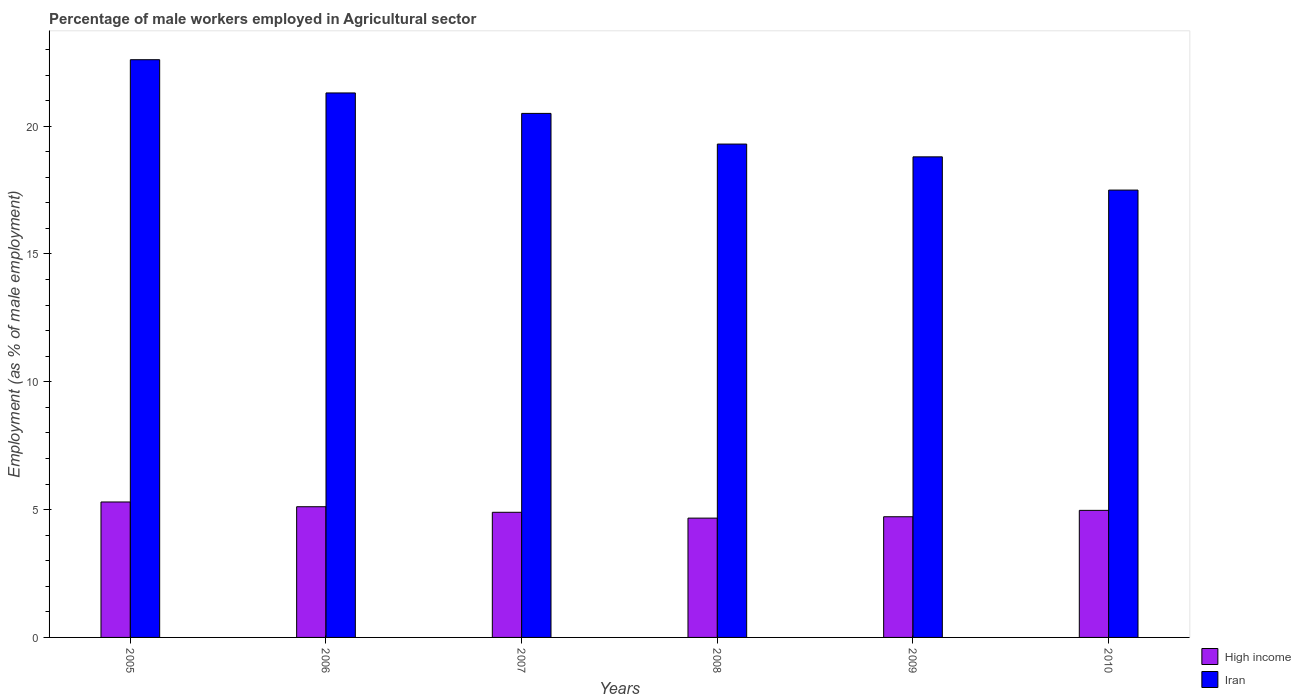How many different coloured bars are there?
Keep it short and to the point. 2. How many groups of bars are there?
Provide a succinct answer. 6. Are the number of bars per tick equal to the number of legend labels?
Provide a short and direct response. Yes. How many bars are there on the 3rd tick from the right?
Provide a succinct answer. 2. What is the label of the 5th group of bars from the left?
Your answer should be very brief. 2009. What is the percentage of male workers employed in Agricultural sector in High income in 2006?
Your answer should be compact. 5.11. Across all years, what is the maximum percentage of male workers employed in Agricultural sector in Iran?
Offer a very short reply. 22.6. In which year was the percentage of male workers employed in Agricultural sector in High income maximum?
Ensure brevity in your answer.  2005. In which year was the percentage of male workers employed in Agricultural sector in High income minimum?
Your response must be concise. 2008. What is the total percentage of male workers employed in Agricultural sector in High income in the graph?
Offer a terse response. 29.67. What is the difference between the percentage of male workers employed in Agricultural sector in High income in 2007 and that in 2009?
Offer a very short reply. 0.17. What is the difference between the percentage of male workers employed in Agricultural sector in Iran in 2007 and the percentage of male workers employed in Agricultural sector in High income in 2006?
Make the answer very short. 15.39. What is the average percentage of male workers employed in Agricultural sector in High income per year?
Offer a terse response. 4.94. In the year 2007, what is the difference between the percentage of male workers employed in Agricultural sector in Iran and percentage of male workers employed in Agricultural sector in High income?
Offer a terse response. 15.6. In how many years, is the percentage of male workers employed in Agricultural sector in High income greater than 20 %?
Offer a terse response. 0. What is the ratio of the percentage of male workers employed in Agricultural sector in High income in 2006 to that in 2010?
Keep it short and to the point. 1.03. Is the difference between the percentage of male workers employed in Agricultural sector in Iran in 2007 and 2009 greater than the difference between the percentage of male workers employed in Agricultural sector in High income in 2007 and 2009?
Your answer should be very brief. Yes. What is the difference between the highest and the second highest percentage of male workers employed in Agricultural sector in Iran?
Ensure brevity in your answer.  1.3. What is the difference between the highest and the lowest percentage of male workers employed in Agricultural sector in High income?
Offer a terse response. 0.63. In how many years, is the percentage of male workers employed in Agricultural sector in Iran greater than the average percentage of male workers employed in Agricultural sector in Iran taken over all years?
Your answer should be very brief. 3. Is the sum of the percentage of male workers employed in Agricultural sector in Iran in 2006 and 2010 greater than the maximum percentage of male workers employed in Agricultural sector in High income across all years?
Ensure brevity in your answer.  Yes. What does the 1st bar from the left in 2006 represents?
Provide a short and direct response. High income. What does the 2nd bar from the right in 2009 represents?
Give a very brief answer. High income. How many bars are there?
Provide a short and direct response. 12. Are all the bars in the graph horizontal?
Keep it short and to the point. No. How many years are there in the graph?
Provide a succinct answer. 6. Are the values on the major ticks of Y-axis written in scientific E-notation?
Your answer should be compact. No. Does the graph contain any zero values?
Make the answer very short. No. How many legend labels are there?
Offer a very short reply. 2. How are the legend labels stacked?
Provide a succinct answer. Vertical. What is the title of the graph?
Keep it short and to the point. Percentage of male workers employed in Agricultural sector. Does "Italy" appear as one of the legend labels in the graph?
Offer a very short reply. No. What is the label or title of the X-axis?
Provide a short and direct response. Years. What is the label or title of the Y-axis?
Your response must be concise. Employment (as % of male employment). What is the Employment (as % of male employment) in High income in 2005?
Provide a succinct answer. 5.3. What is the Employment (as % of male employment) of Iran in 2005?
Provide a succinct answer. 22.6. What is the Employment (as % of male employment) of High income in 2006?
Your answer should be very brief. 5.11. What is the Employment (as % of male employment) in Iran in 2006?
Your answer should be compact. 21.3. What is the Employment (as % of male employment) of High income in 2007?
Make the answer very short. 4.9. What is the Employment (as % of male employment) of Iran in 2007?
Your response must be concise. 20.5. What is the Employment (as % of male employment) of High income in 2008?
Make the answer very short. 4.67. What is the Employment (as % of male employment) of Iran in 2008?
Provide a succinct answer. 19.3. What is the Employment (as % of male employment) in High income in 2009?
Keep it short and to the point. 4.72. What is the Employment (as % of male employment) of Iran in 2009?
Make the answer very short. 18.8. What is the Employment (as % of male employment) in High income in 2010?
Keep it short and to the point. 4.97. What is the Employment (as % of male employment) in Iran in 2010?
Offer a terse response. 17.5. Across all years, what is the maximum Employment (as % of male employment) of High income?
Ensure brevity in your answer.  5.3. Across all years, what is the maximum Employment (as % of male employment) of Iran?
Your response must be concise. 22.6. Across all years, what is the minimum Employment (as % of male employment) in High income?
Offer a terse response. 4.67. What is the total Employment (as % of male employment) of High income in the graph?
Ensure brevity in your answer.  29.67. What is the total Employment (as % of male employment) in Iran in the graph?
Give a very brief answer. 120. What is the difference between the Employment (as % of male employment) in High income in 2005 and that in 2006?
Offer a terse response. 0.19. What is the difference between the Employment (as % of male employment) of Iran in 2005 and that in 2006?
Offer a very short reply. 1.3. What is the difference between the Employment (as % of male employment) of High income in 2005 and that in 2007?
Make the answer very short. 0.4. What is the difference between the Employment (as % of male employment) of High income in 2005 and that in 2008?
Ensure brevity in your answer.  0.63. What is the difference between the Employment (as % of male employment) in Iran in 2005 and that in 2008?
Offer a very short reply. 3.3. What is the difference between the Employment (as % of male employment) of High income in 2005 and that in 2009?
Ensure brevity in your answer.  0.58. What is the difference between the Employment (as % of male employment) in Iran in 2005 and that in 2009?
Your response must be concise. 3.8. What is the difference between the Employment (as % of male employment) of High income in 2005 and that in 2010?
Keep it short and to the point. 0.33. What is the difference between the Employment (as % of male employment) in High income in 2006 and that in 2007?
Your answer should be very brief. 0.22. What is the difference between the Employment (as % of male employment) in Iran in 2006 and that in 2007?
Ensure brevity in your answer.  0.8. What is the difference between the Employment (as % of male employment) of High income in 2006 and that in 2008?
Your answer should be very brief. 0.45. What is the difference between the Employment (as % of male employment) in High income in 2006 and that in 2009?
Provide a succinct answer. 0.39. What is the difference between the Employment (as % of male employment) of High income in 2006 and that in 2010?
Your answer should be very brief. 0.14. What is the difference between the Employment (as % of male employment) in Iran in 2006 and that in 2010?
Your answer should be very brief. 3.8. What is the difference between the Employment (as % of male employment) in High income in 2007 and that in 2008?
Give a very brief answer. 0.23. What is the difference between the Employment (as % of male employment) of Iran in 2007 and that in 2008?
Make the answer very short. 1.2. What is the difference between the Employment (as % of male employment) in High income in 2007 and that in 2009?
Make the answer very short. 0.17. What is the difference between the Employment (as % of male employment) of Iran in 2007 and that in 2009?
Your answer should be compact. 1.7. What is the difference between the Employment (as % of male employment) of High income in 2007 and that in 2010?
Provide a short and direct response. -0.08. What is the difference between the Employment (as % of male employment) of High income in 2008 and that in 2009?
Provide a succinct answer. -0.05. What is the difference between the Employment (as % of male employment) in High income in 2008 and that in 2010?
Ensure brevity in your answer.  -0.3. What is the difference between the Employment (as % of male employment) of Iran in 2008 and that in 2010?
Your answer should be very brief. 1.8. What is the difference between the Employment (as % of male employment) in High income in 2009 and that in 2010?
Ensure brevity in your answer.  -0.25. What is the difference between the Employment (as % of male employment) in Iran in 2009 and that in 2010?
Your answer should be very brief. 1.3. What is the difference between the Employment (as % of male employment) in High income in 2005 and the Employment (as % of male employment) in Iran in 2006?
Give a very brief answer. -16. What is the difference between the Employment (as % of male employment) in High income in 2005 and the Employment (as % of male employment) in Iran in 2007?
Offer a terse response. -15.2. What is the difference between the Employment (as % of male employment) of High income in 2005 and the Employment (as % of male employment) of Iran in 2008?
Provide a succinct answer. -14. What is the difference between the Employment (as % of male employment) in High income in 2005 and the Employment (as % of male employment) in Iran in 2009?
Your answer should be compact. -13.5. What is the difference between the Employment (as % of male employment) in High income in 2005 and the Employment (as % of male employment) in Iran in 2010?
Your answer should be compact. -12.2. What is the difference between the Employment (as % of male employment) of High income in 2006 and the Employment (as % of male employment) of Iran in 2007?
Your response must be concise. -15.39. What is the difference between the Employment (as % of male employment) in High income in 2006 and the Employment (as % of male employment) in Iran in 2008?
Make the answer very short. -14.19. What is the difference between the Employment (as % of male employment) in High income in 2006 and the Employment (as % of male employment) in Iran in 2009?
Give a very brief answer. -13.69. What is the difference between the Employment (as % of male employment) of High income in 2006 and the Employment (as % of male employment) of Iran in 2010?
Your answer should be compact. -12.39. What is the difference between the Employment (as % of male employment) of High income in 2007 and the Employment (as % of male employment) of Iran in 2008?
Provide a succinct answer. -14.4. What is the difference between the Employment (as % of male employment) in High income in 2007 and the Employment (as % of male employment) in Iran in 2009?
Provide a short and direct response. -13.9. What is the difference between the Employment (as % of male employment) in High income in 2007 and the Employment (as % of male employment) in Iran in 2010?
Your response must be concise. -12.6. What is the difference between the Employment (as % of male employment) in High income in 2008 and the Employment (as % of male employment) in Iran in 2009?
Your response must be concise. -14.13. What is the difference between the Employment (as % of male employment) of High income in 2008 and the Employment (as % of male employment) of Iran in 2010?
Make the answer very short. -12.83. What is the difference between the Employment (as % of male employment) in High income in 2009 and the Employment (as % of male employment) in Iran in 2010?
Your answer should be compact. -12.78. What is the average Employment (as % of male employment) of High income per year?
Offer a terse response. 4.94. What is the average Employment (as % of male employment) of Iran per year?
Give a very brief answer. 20. In the year 2005, what is the difference between the Employment (as % of male employment) of High income and Employment (as % of male employment) of Iran?
Your answer should be very brief. -17.3. In the year 2006, what is the difference between the Employment (as % of male employment) in High income and Employment (as % of male employment) in Iran?
Provide a succinct answer. -16.19. In the year 2007, what is the difference between the Employment (as % of male employment) in High income and Employment (as % of male employment) in Iran?
Your response must be concise. -15.6. In the year 2008, what is the difference between the Employment (as % of male employment) in High income and Employment (as % of male employment) in Iran?
Your response must be concise. -14.63. In the year 2009, what is the difference between the Employment (as % of male employment) of High income and Employment (as % of male employment) of Iran?
Your response must be concise. -14.08. In the year 2010, what is the difference between the Employment (as % of male employment) in High income and Employment (as % of male employment) in Iran?
Give a very brief answer. -12.53. What is the ratio of the Employment (as % of male employment) of High income in 2005 to that in 2006?
Give a very brief answer. 1.04. What is the ratio of the Employment (as % of male employment) of Iran in 2005 to that in 2006?
Make the answer very short. 1.06. What is the ratio of the Employment (as % of male employment) in High income in 2005 to that in 2007?
Your response must be concise. 1.08. What is the ratio of the Employment (as % of male employment) in Iran in 2005 to that in 2007?
Ensure brevity in your answer.  1.1. What is the ratio of the Employment (as % of male employment) of High income in 2005 to that in 2008?
Your answer should be very brief. 1.14. What is the ratio of the Employment (as % of male employment) in Iran in 2005 to that in 2008?
Keep it short and to the point. 1.17. What is the ratio of the Employment (as % of male employment) in High income in 2005 to that in 2009?
Offer a very short reply. 1.12. What is the ratio of the Employment (as % of male employment) of Iran in 2005 to that in 2009?
Make the answer very short. 1.2. What is the ratio of the Employment (as % of male employment) in High income in 2005 to that in 2010?
Your answer should be very brief. 1.07. What is the ratio of the Employment (as % of male employment) of Iran in 2005 to that in 2010?
Ensure brevity in your answer.  1.29. What is the ratio of the Employment (as % of male employment) of High income in 2006 to that in 2007?
Keep it short and to the point. 1.04. What is the ratio of the Employment (as % of male employment) in Iran in 2006 to that in 2007?
Your answer should be very brief. 1.04. What is the ratio of the Employment (as % of male employment) in High income in 2006 to that in 2008?
Provide a succinct answer. 1.1. What is the ratio of the Employment (as % of male employment) of Iran in 2006 to that in 2008?
Provide a succinct answer. 1.1. What is the ratio of the Employment (as % of male employment) of High income in 2006 to that in 2009?
Ensure brevity in your answer.  1.08. What is the ratio of the Employment (as % of male employment) in Iran in 2006 to that in 2009?
Provide a short and direct response. 1.13. What is the ratio of the Employment (as % of male employment) of High income in 2006 to that in 2010?
Your answer should be compact. 1.03. What is the ratio of the Employment (as % of male employment) in Iran in 2006 to that in 2010?
Ensure brevity in your answer.  1.22. What is the ratio of the Employment (as % of male employment) in High income in 2007 to that in 2008?
Your answer should be very brief. 1.05. What is the ratio of the Employment (as % of male employment) in Iran in 2007 to that in 2008?
Make the answer very short. 1.06. What is the ratio of the Employment (as % of male employment) in High income in 2007 to that in 2009?
Provide a short and direct response. 1.04. What is the ratio of the Employment (as % of male employment) of Iran in 2007 to that in 2009?
Your answer should be compact. 1.09. What is the ratio of the Employment (as % of male employment) in High income in 2007 to that in 2010?
Your answer should be compact. 0.98. What is the ratio of the Employment (as % of male employment) of Iran in 2007 to that in 2010?
Give a very brief answer. 1.17. What is the ratio of the Employment (as % of male employment) in High income in 2008 to that in 2009?
Ensure brevity in your answer.  0.99. What is the ratio of the Employment (as % of male employment) in Iran in 2008 to that in 2009?
Your response must be concise. 1.03. What is the ratio of the Employment (as % of male employment) in High income in 2008 to that in 2010?
Ensure brevity in your answer.  0.94. What is the ratio of the Employment (as % of male employment) of Iran in 2008 to that in 2010?
Provide a short and direct response. 1.1. What is the ratio of the Employment (as % of male employment) of High income in 2009 to that in 2010?
Your answer should be very brief. 0.95. What is the ratio of the Employment (as % of male employment) in Iran in 2009 to that in 2010?
Your response must be concise. 1.07. What is the difference between the highest and the second highest Employment (as % of male employment) in High income?
Offer a terse response. 0.19. What is the difference between the highest and the lowest Employment (as % of male employment) in High income?
Your answer should be very brief. 0.63. What is the difference between the highest and the lowest Employment (as % of male employment) of Iran?
Provide a short and direct response. 5.1. 